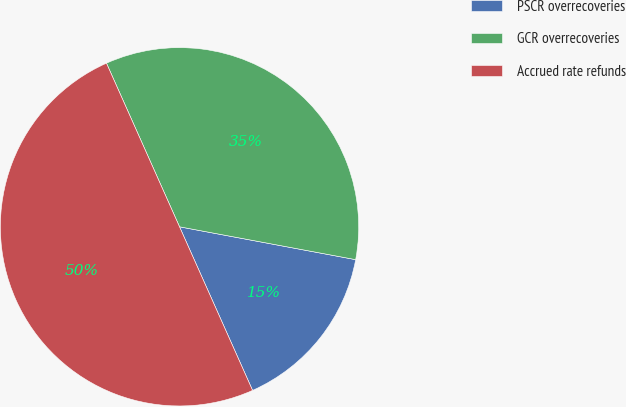Convert chart. <chart><loc_0><loc_0><loc_500><loc_500><pie_chart><fcel>PSCR overrecoveries<fcel>GCR overrecoveries<fcel>Accrued rate refunds<nl><fcel>15.38%<fcel>34.62%<fcel>50.0%<nl></chart> 